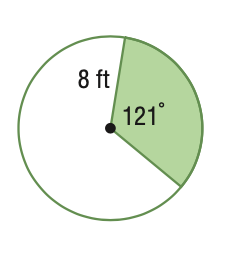Answer the mathemtical geometry problem and directly provide the correct option letter.
Question: Find the area of the sector. Round to the nearest tenth.
Choices: A: 16.9 B: 67.6 C: 133.5 D: 201.1 B 